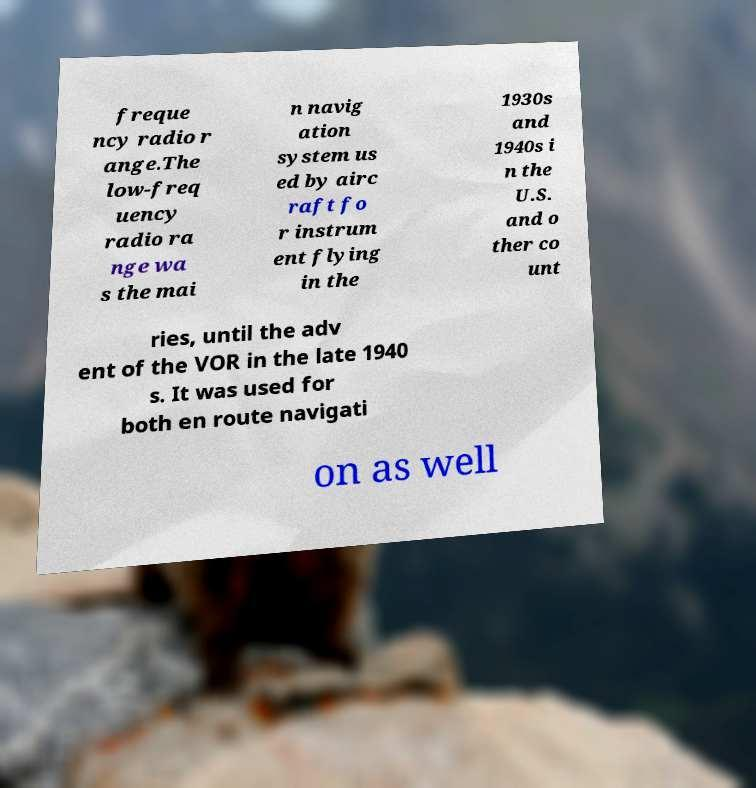There's text embedded in this image that I need extracted. Can you transcribe it verbatim? freque ncy radio r ange.The low-freq uency radio ra nge wa s the mai n navig ation system us ed by airc raft fo r instrum ent flying in the 1930s and 1940s i n the U.S. and o ther co unt ries, until the adv ent of the VOR in the late 1940 s. It was used for both en route navigati on as well 